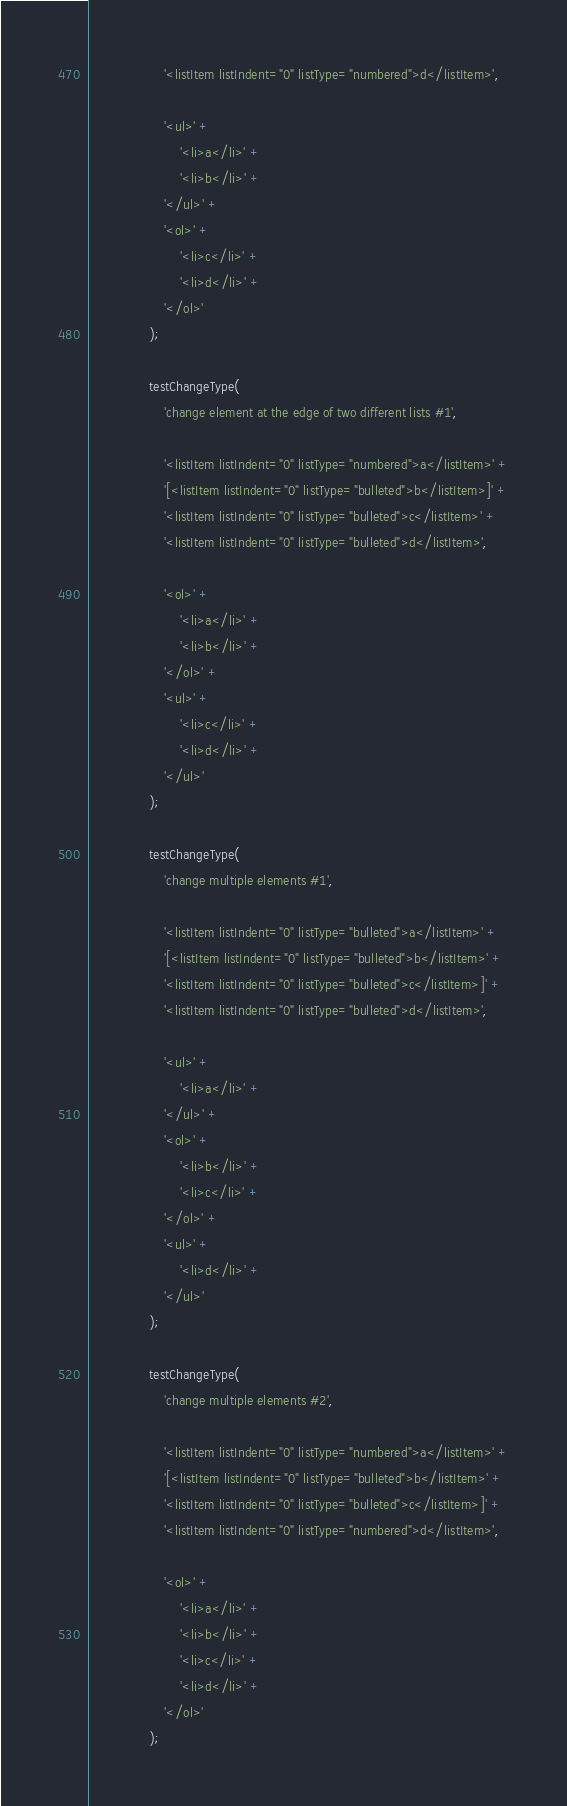Convert code to text. <code><loc_0><loc_0><loc_500><loc_500><_JavaScript_>					'<listItem listIndent="0" listType="numbered">d</listItem>',

					'<ul>' +
						'<li>a</li>' +
						'<li>b</li>' +
					'</ul>' +
					'<ol>' +
						'<li>c</li>' +
						'<li>d</li>' +
					'</ol>'
				);

				testChangeType(
					'change element at the edge of two different lists #1',

					'<listItem listIndent="0" listType="numbered">a</listItem>' +
					'[<listItem listIndent="0" listType="bulleted">b</listItem>]' +
					'<listItem listIndent="0" listType="bulleted">c</listItem>' +
					'<listItem listIndent="0" listType="bulleted">d</listItem>',

					'<ol>' +
						'<li>a</li>' +
						'<li>b</li>' +
					'</ol>' +
					'<ul>' +
						'<li>c</li>' +
						'<li>d</li>' +
					'</ul>'
				);

				testChangeType(
					'change multiple elements #1',

					'<listItem listIndent="0" listType="bulleted">a</listItem>' +
					'[<listItem listIndent="0" listType="bulleted">b</listItem>' +
					'<listItem listIndent="0" listType="bulleted">c</listItem>]' +
					'<listItem listIndent="0" listType="bulleted">d</listItem>',

					'<ul>' +
						'<li>a</li>' +
					'</ul>' +
					'<ol>' +
						'<li>b</li>' +
						'<li>c</li>' +
					'</ol>' +
					'<ul>' +
						'<li>d</li>' +
					'</ul>'
				);

				testChangeType(
					'change multiple elements #2',

					'<listItem listIndent="0" listType="numbered">a</listItem>' +
					'[<listItem listIndent="0" listType="bulleted">b</listItem>' +
					'<listItem listIndent="0" listType="bulleted">c</listItem>]' +
					'<listItem listIndent="0" listType="numbered">d</listItem>',

					'<ol>' +
						'<li>a</li>' +
						'<li>b</li>' +
						'<li>c</li>' +
						'<li>d</li>' +
					'</ol>'
				);</code> 